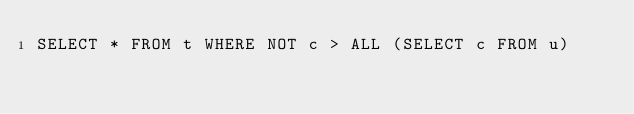<code> <loc_0><loc_0><loc_500><loc_500><_SQL_>SELECT * FROM t WHERE NOT c > ALL (SELECT c FROM u)</code> 